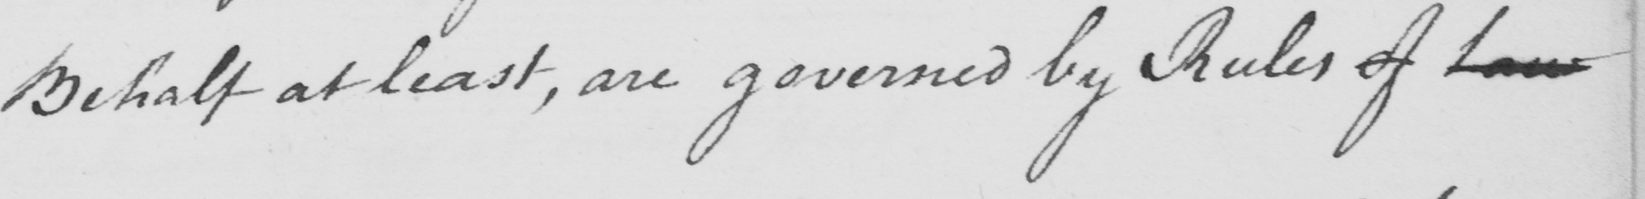Please transcribe the handwritten text in this image. Behalf at least , are governed by Rules of Law 